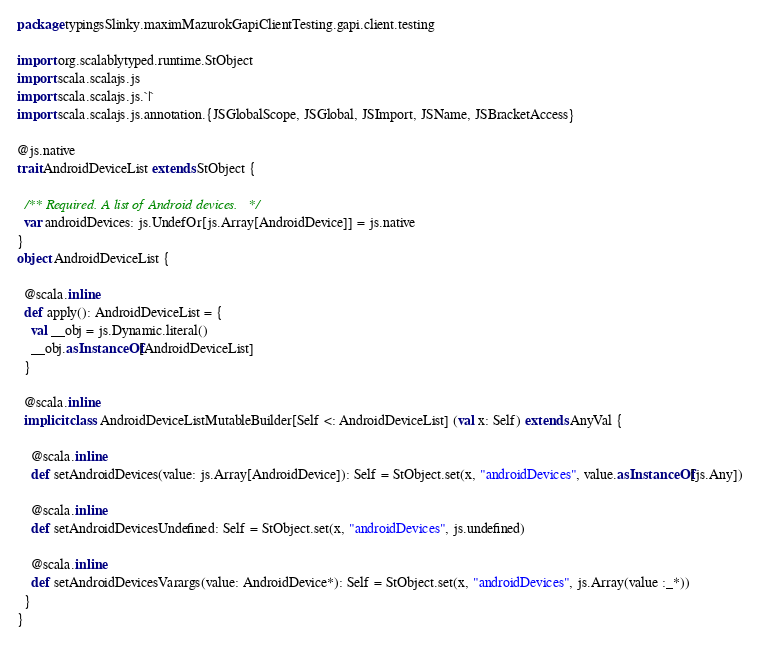Convert code to text. <code><loc_0><loc_0><loc_500><loc_500><_Scala_>package typingsSlinky.maximMazurokGapiClientTesting.gapi.client.testing

import org.scalablytyped.runtime.StObject
import scala.scalajs.js
import scala.scalajs.js.`|`
import scala.scalajs.js.annotation.{JSGlobalScope, JSGlobal, JSImport, JSName, JSBracketAccess}

@js.native
trait AndroidDeviceList extends StObject {
  
  /** Required. A list of Android devices. */
  var androidDevices: js.UndefOr[js.Array[AndroidDevice]] = js.native
}
object AndroidDeviceList {
  
  @scala.inline
  def apply(): AndroidDeviceList = {
    val __obj = js.Dynamic.literal()
    __obj.asInstanceOf[AndroidDeviceList]
  }
  
  @scala.inline
  implicit class AndroidDeviceListMutableBuilder[Self <: AndroidDeviceList] (val x: Self) extends AnyVal {
    
    @scala.inline
    def setAndroidDevices(value: js.Array[AndroidDevice]): Self = StObject.set(x, "androidDevices", value.asInstanceOf[js.Any])
    
    @scala.inline
    def setAndroidDevicesUndefined: Self = StObject.set(x, "androidDevices", js.undefined)
    
    @scala.inline
    def setAndroidDevicesVarargs(value: AndroidDevice*): Self = StObject.set(x, "androidDevices", js.Array(value :_*))
  }
}
</code> 